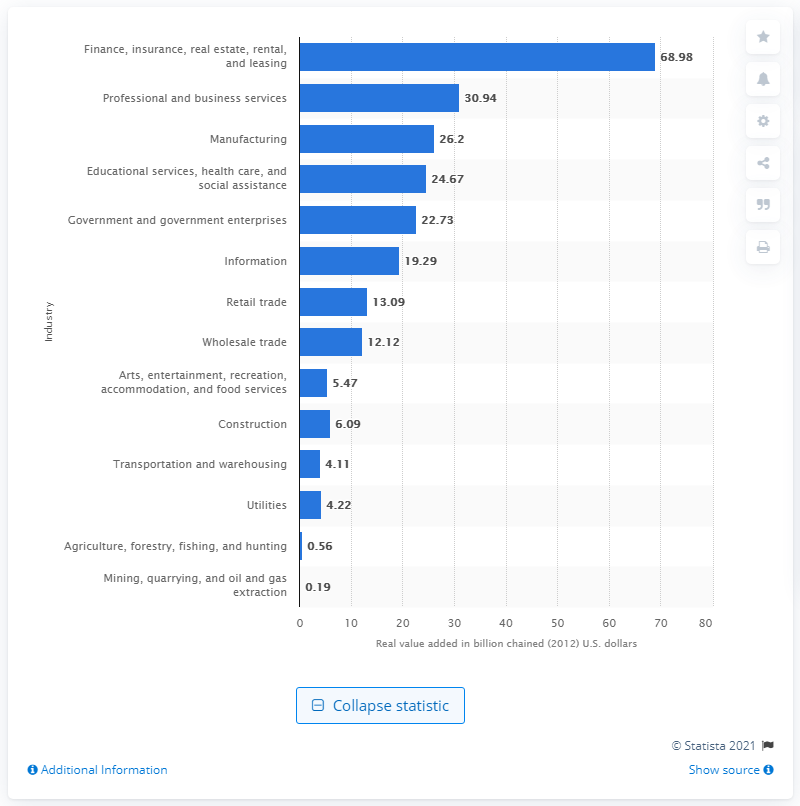How much money did the finance, insurance, real estate, rental, and leasing industry contribute to Connecticut's GDP in 2020? In 2020, the finance, insurance, real estate, rental, and leasing industry made a significant contribution to Connecticut's GDP, amounting to $68.98 billion in real value added, which reflects its large role in the state's economy. 